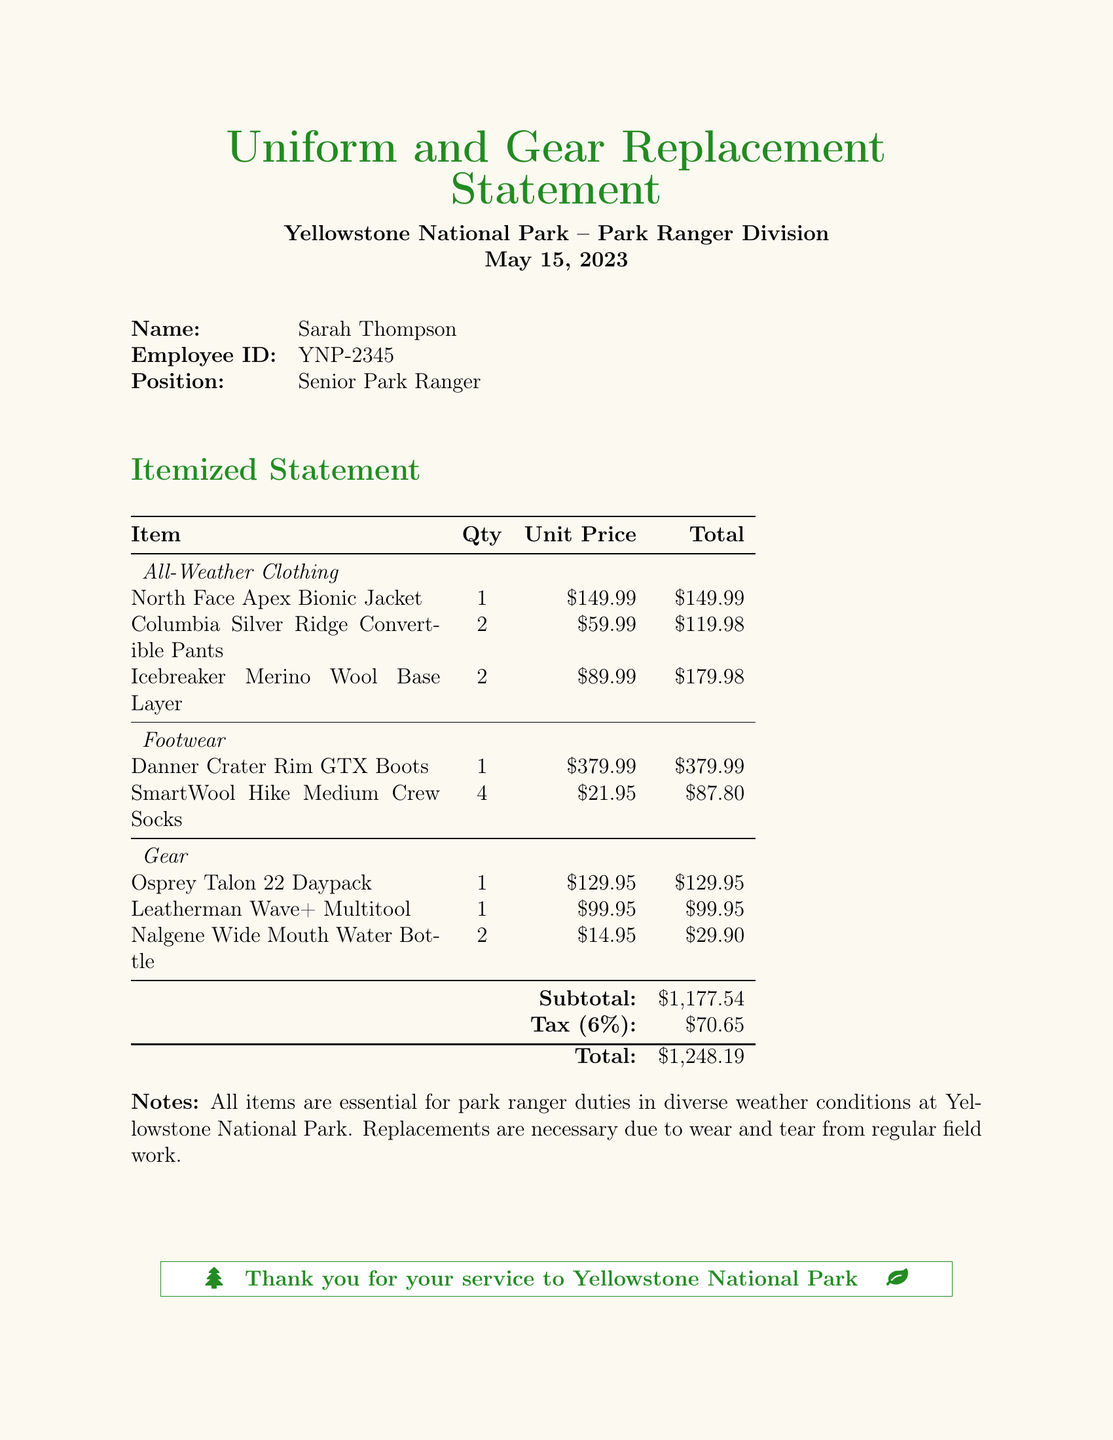What is the employee's name? The employee's name is stated at the beginning of the document.
Answer: Sarah Thompson What is the employee ID? The employee ID is provided in the document as part of the employee details.
Answer: YNP-2345 What is the total amount after tax? The total amount after tax is indicated in the summary of the statement.
Answer: $1,248.19 How many pairs of Columbia Silver Ridge Convertible Pants were replaced? The quantity for the Columbia Silver Ridge Convertible Pants is listed in the itemized section.
Answer: 2 What is the unit price of the Danner Crater Rim GTX Boots? The unit price for the Danner Crater Rim GTX Boots is specified in the document.
Answer: $379.99 What tax percentage is applied in this statement? The tax percentage applied for the total is mentioned in the summary of the document.
Answer: 6% What is the subtotal before tax? The subtotal before tax is clearly stated in the document right before the tax calculation.
Answer: $1,177.54 Which item has the highest unit price? The item with the highest unit price can be found in the itemized statement section.
Answer: Danner Crater Rim GTX Boots What is the date of the statement? The date of the statement is mentioned at the top of the document.
Answer: May 15, 2023 